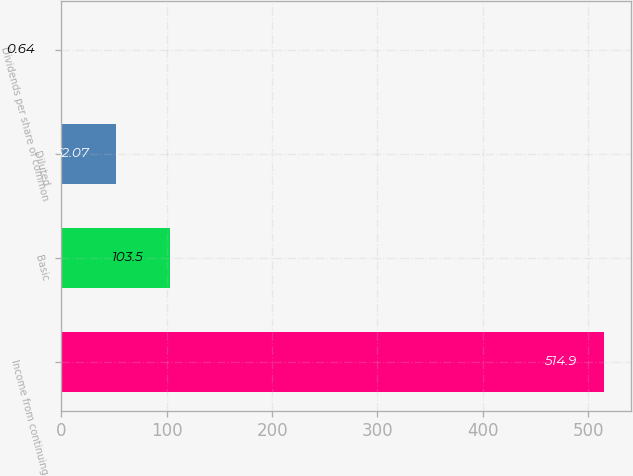Convert chart. <chart><loc_0><loc_0><loc_500><loc_500><bar_chart><fcel>Income from continuing<fcel>Basic<fcel>Diluted<fcel>Dividends per share of common<nl><fcel>514.9<fcel>103.5<fcel>52.07<fcel>0.64<nl></chart> 